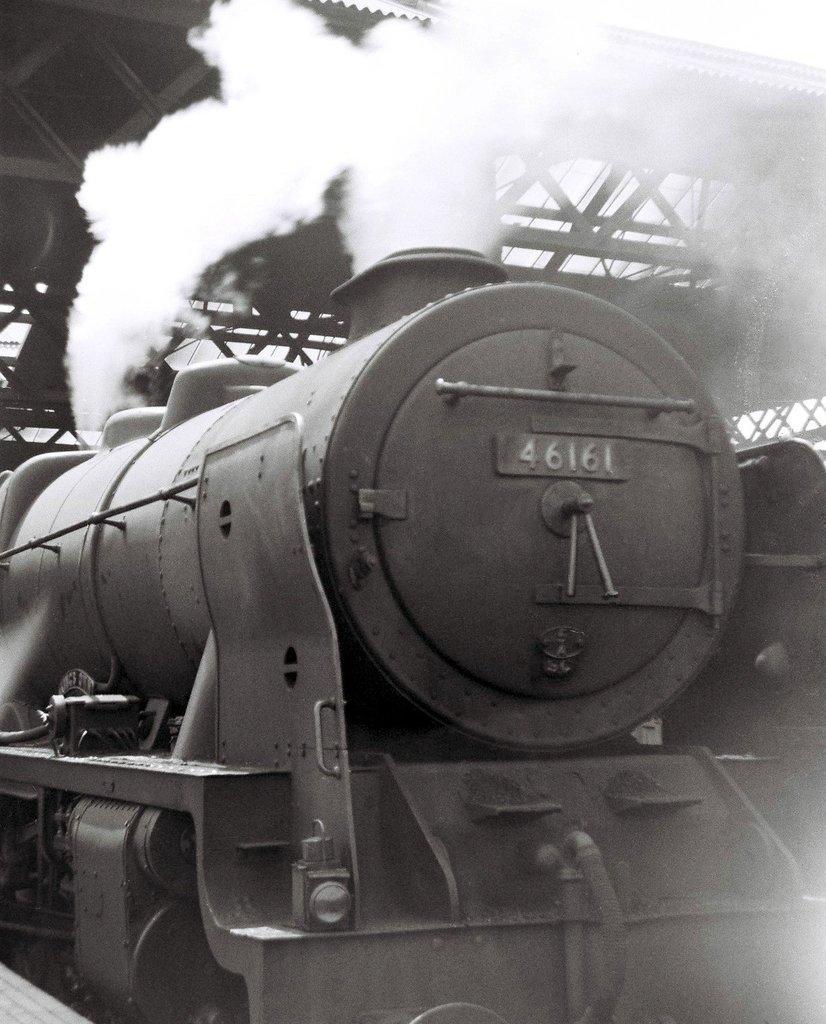Describe this image in one or two sentences. This is a black and white image where we can see a train engine, smoke and foot over bridge. 